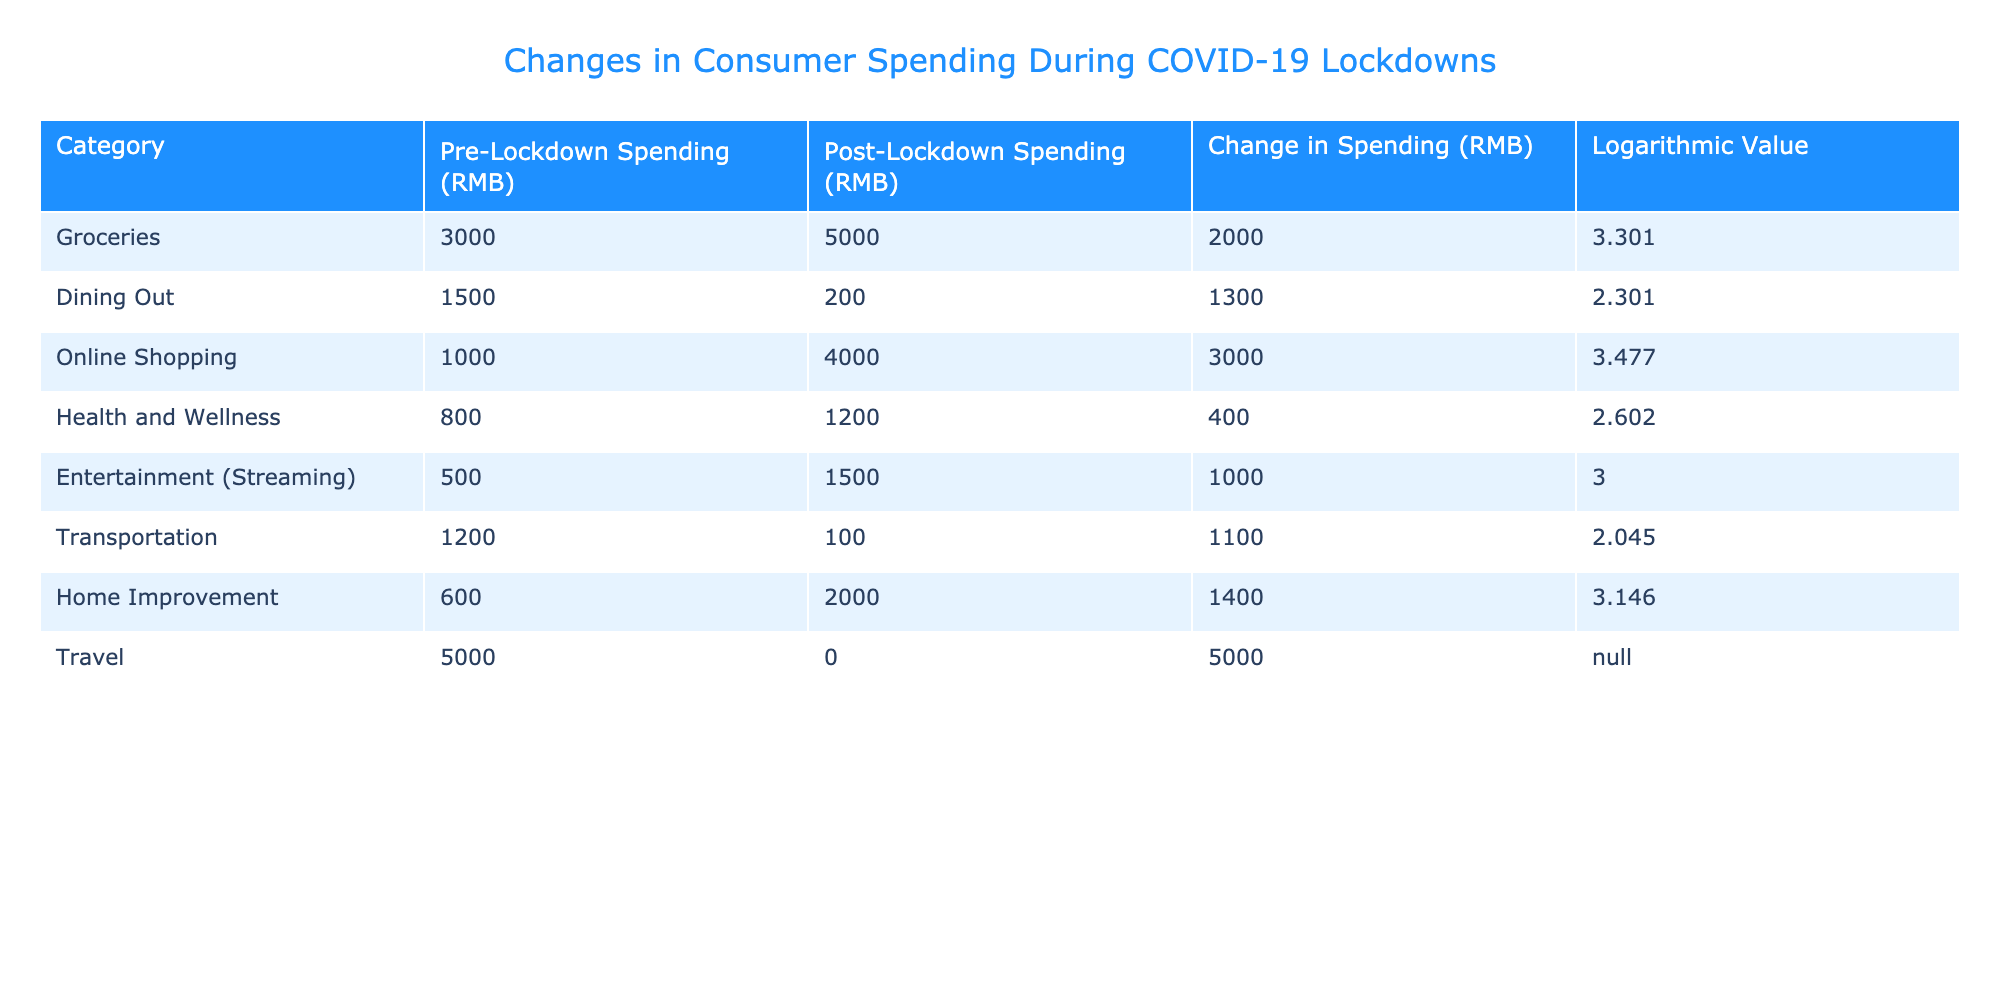What was the change in spending on dining out during the lockdown? According to the table, the pre-lockdown spending on dining out was 1500 RMB, and the post-lockdown spending was 200 RMB. Therefore, the change in spending is calculated as 200 - 1500 = -1300 RMB.
Answer: -1300 RMB Which category experienced the highest change in spending during the lockdown? From the table, we see that the Travel category had the highest change in spending, with a decrease of 5000 RMB, as it went from 5000 RMB pre-lockdown to 0 RMB post-lockdown.
Answer: Travel What is the total change in spending across all categories? We can sum the changes in spending for each category, which are 2000, -1300, 3000, 400, 1000, -1100, 1400, and -5000. Adding these up gives us 2000 - 1300 + 3000 + 400 + 1000 - 1100 + 1400 - 5000 = -1600 RMB.
Answer: -1600 RMB Did spending on Health and Wellness increase or decrease after the lockdown? The pre-lockdown spending on Health and Wellness was 800 RMB, while post-lockdown spending increased to 1200 RMB. Thus, spending increased during the lockdown.
Answer: Yes Which spending category had the highest logarithmic value after the lockdown, and what was that value? When we review the logarithmic values, Online Shopping has the highest value of 3.477 following the lockdown, indicating a significant increase in consumer spending in this area.
Answer: 3.477 